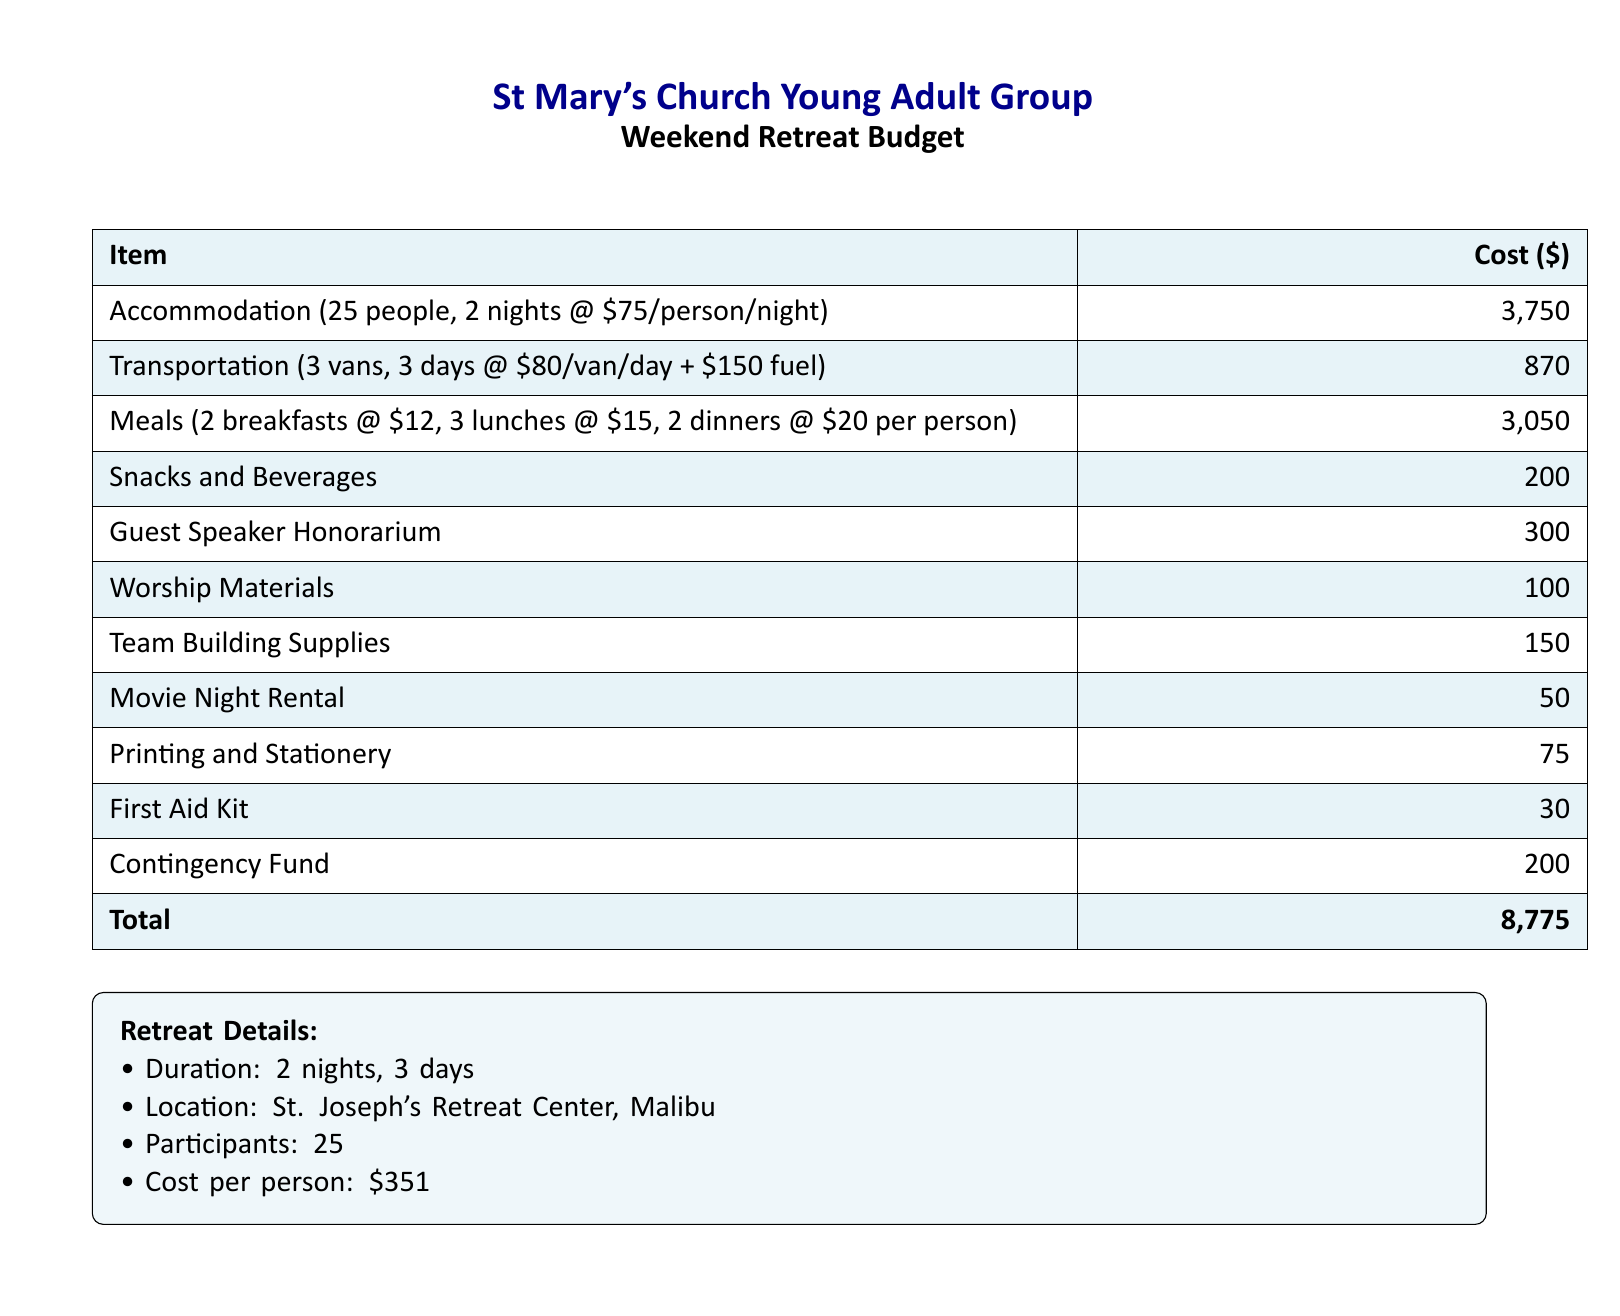What is the total cost? The total cost is provided in the budget summary at the bottom of the table.
Answer: 8,775 How many people will attend the retreat? The number of participants is mentioned in the "Retreat Details" section.
Answer: 25 What is the cost per person for the retreat? The cost per person is calculated and specified in the "Retreat Details" section.
Answer: 351 How much is allocated for meals? The cost of meals is detailed in the budget table under "Meals."
Answer: 3,050 What is the cost of accommodation for 2 nights? Accommodation costs are provided in the budget table, which specifies the cost for two nights for all participants.
Answer: 3,750 What is the honorarium for the guest speaker? The budget outlines a specific line item for the guest speaker's honorarium.
Answer: 300 How much funds are set aside for the contingency fund? The amount designated for unexpected expenses is stated in the budget.
Answer: 200 Where will the retreat take place? The location of the retreat is provided in the "Retreat Details" section.
Answer: St. Joseph's Retreat Center, Malibu What are the costs for transportation? Transportation expenses are summarized in the budget table under "Transportation."
Answer: 870 What item has the lowest cost listed in the budget? The lowest cost item is mentioned in the budget table.
Answer: 30 